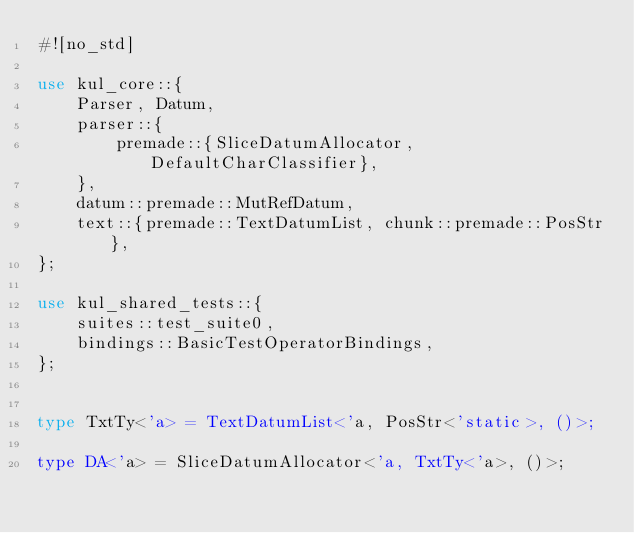<code> <loc_0><loc_0><loc_500><loc_500><_Rust_>#![no_std]

use kul_core::{
    Parser, Datum,
    parser::{
        premade::{SliceDatumAllocator, DefaultCharClassifier},
    },
    datum::premade::MutRefDatum,
    text::{premade::TextDatumList, chunk::premade::PosStr},
};

use kul_shared_tests::{
    suites::test_suite0,
    bindings::BasicTestOperatorBindings,
};


type TxtTy<'a> = TextDatumList<'a, PosStr<'static>, ()>;

type DA<'a> = SliceDatumAllocator<'a, TxtTy<'a>, ()>;
</code> 